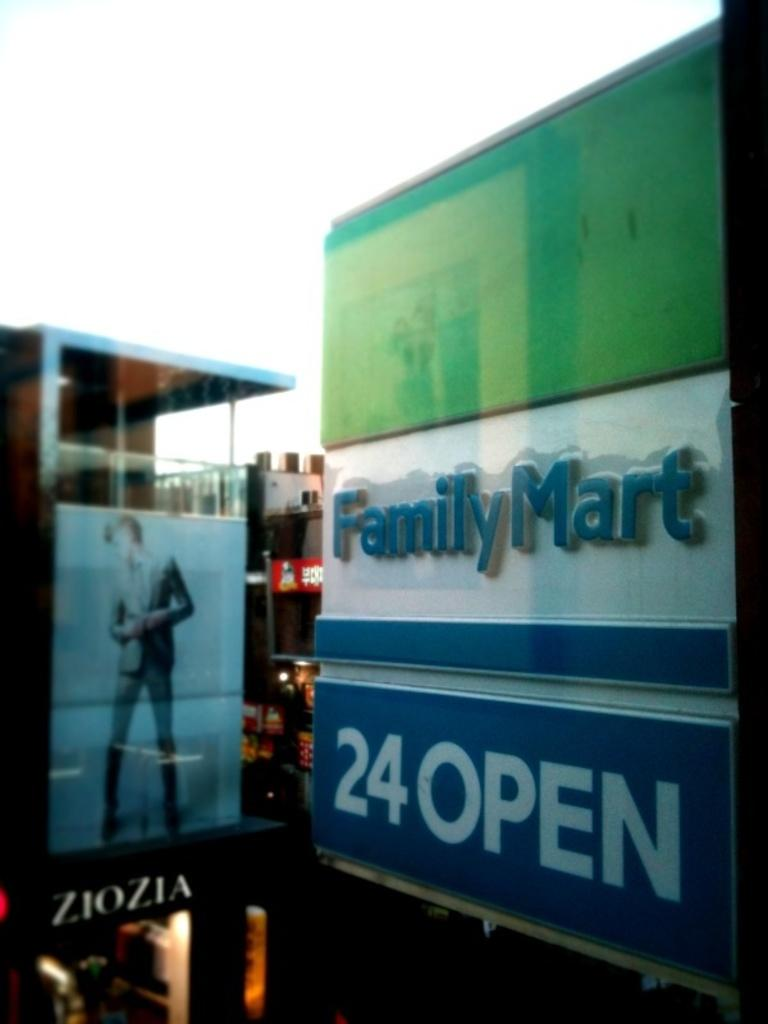<image>
Give a short and clear explanation of the subsequent image. A large sign for Family Mart tells the public it is open 24 hours. 